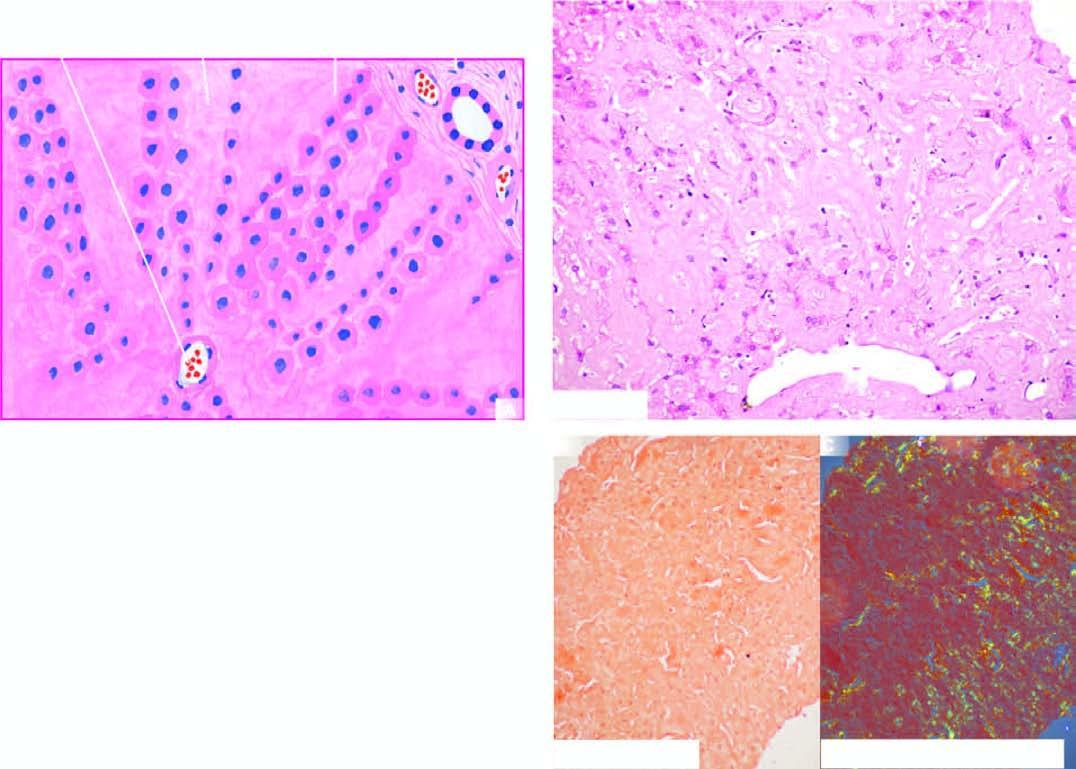does m phase show congophilia which under polarising microscopy?
Answer the question using a single word or phrase. No 